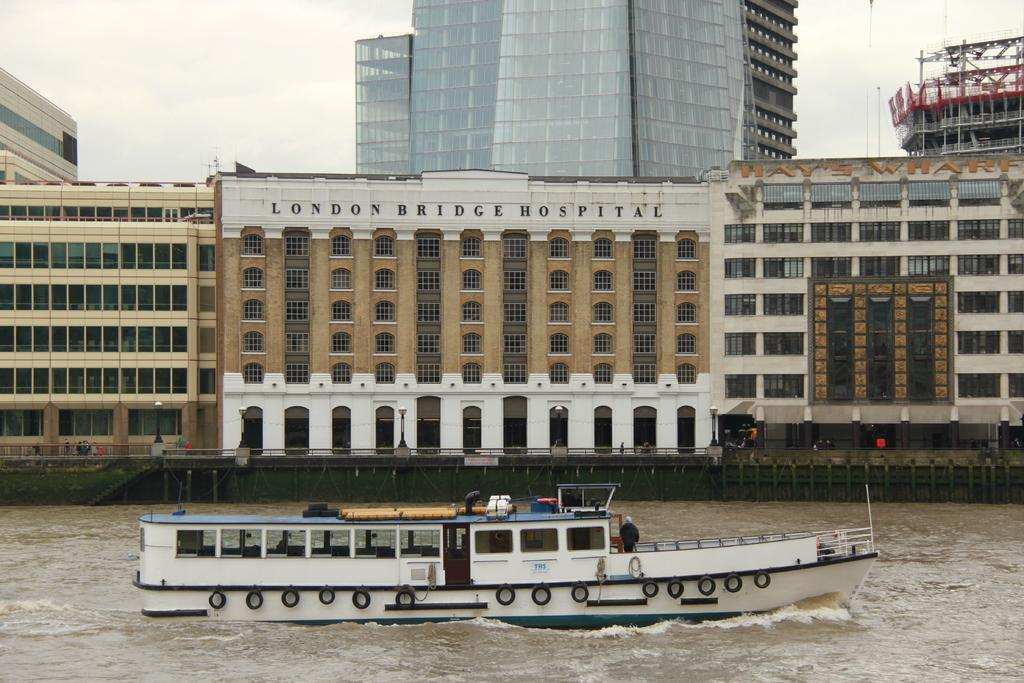Provide a one-sentence caption for the provided image. The boat sails past the London Bridge Hospital. 